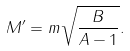<formula> <loc_0><loc_0><loc_500><loc_500>M ^ { \prime } = m \sqrt { \frac { B } { A - 1 } } .</formula> 